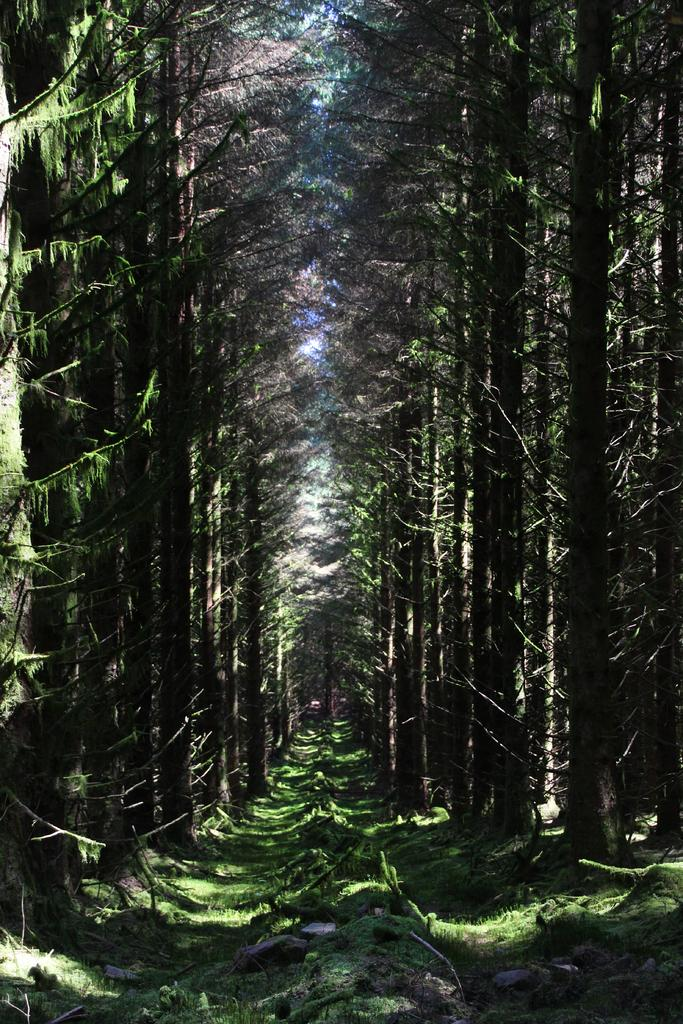What type of vegetation can be seen in the image? There are trees, plants, and grass visible in the image. What is the color of the sky in the background? The sky is blue in the background. Are there any additional features in the sky? Yes, there are clouds in the sky in the background. What type of board is being offered to the quiver in the image? There is no board or quiver present in the image. 